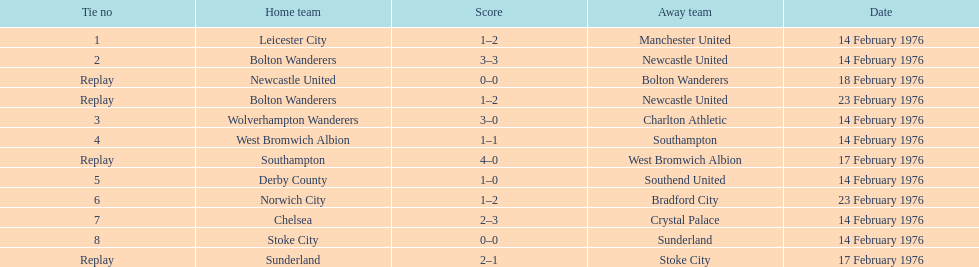What was the number of games that occurred on 14 february 1976? 7. 